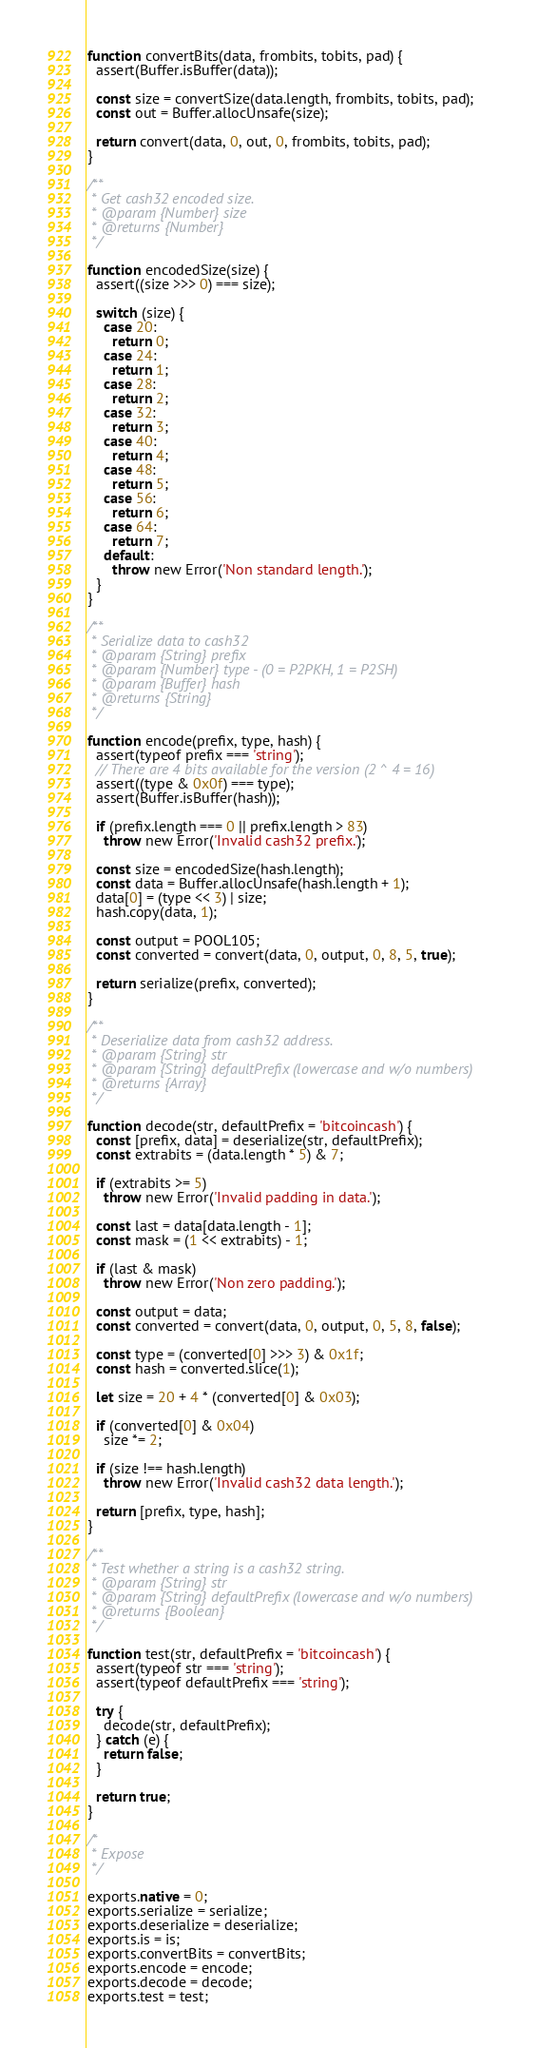Convert code to text. <code><loc_0><loc_0><loc_500><loc_500><_JavaScript_>function convertBits(data, frombits, tobits, pad) {
  assert(Buffer.isBuffer(data));

  const size = convertSize(data.length, frombits, tobits, pad);
  const out = Buffer.allocUnsafe(size);

  return convert(data, 0, out, 0, frombits, tobits, pad);
}

/**
 * Get cash32 encoded size.
 * @param {Number} size
 * @returns {Number}
 */

function encodedSize(size) {
  assert((size >>> 0) === size);

  switch (size) {
    case 20:
      return 0;
    case 24:
      return 1;
    case 28:
      return 2;
    case 32:
      return 3;
    case 40:
      return 4;
    case 48:
      return 5;
    case 56:
      return 6;
    case 64:
      return 7;
    default:
      throw new Error('Non standard length.');
  }
}

/**
 * Serialize data to cash32
 * @param {String} prefix
 * @param {Number} type - (0 = P2PKH, 1 = P2SH)
 * @param {Buffer} hash
 * @returns {String}
 */

function encode(prefix, type, hash) {
  assert(typeof prefix === 'string');
  // There are 4 bits available for the version (2 ^ 4 = 16)
  assert((type & 0x0f) === type);
  assert(Buffer.isBuffer(hash));

  if (prefix.length === 0 || prefix.length > 83)
    throw new Error('Invalid cash32 prefix.');

  const size = encodedSize(hash.length);
  const data = Buffer.allocUnsafe(hash.length + 1);
  data[0] = (type << 3) | size;
  hash.copy(data, 1);

  const output = POOL105;
  const converted = convert(data, 0, output, 0, 8, 5, true);

  return serialize(prefix, converted);
}

/**
 * Deserialize data from cash32 address.
 * @param {String} str
 * @param {String} defaultPrefix (lowercase and w/o numbers)
 * @returns {Array}
 */

function decode(str, defaultPrefix = 'bitcoincash') {
  const [prefix, data] = deserialize(str, defaultPrefix);
  const extrabits = (data.length * 5) & 7;

  if (extrabits >= 5)
    throw new Error('Invalid padding in data.');

  const last = data[data.length - 1];
  const mask = (1 << extrabits) - 1;

  if (last & mask)
    throw new Error('Non zero padding.');

  const output = data;
  const converted = convert(data, 0, output, 0, 5, 8, false);

  const type = (converted[0] >>> 3) & 0x1f;
  const hash = converted.slice(1);

  let size = 20 + 4 * (converted[0] & 0x03);

  if (converted[0] & 0x04)
    size *= 2;

  if (size !== hash.length)
    throw new Error('Invalid cash32 data length.');

  return [prefix, type, hash];
}

/**
 * Test whether a string is a cash32 string.
 * @param {String} str
 * @param {String} defaultPrefix (lowercase and w/o numbers)
 * @returns {Boolean}
 */

function test(str, defaultPrefix = 'bitcoincash') {
  assert(typeof str === 'string');
  assert(typeof defaultPrefix === 'string');

  try {
    decode(str, defaultPrefix);
  } catch (e) {
    return false;
  }

  return true;
}

/*
 * Expose
 */

exports.native = 0;
exports.serialize = serialize;
exports.deserialize = deserialize;
exports.is = is;
exports.convertBits = convertBits;
exports.encode = encode;
exports.decode = decode;
exports.test = test;
</code> 